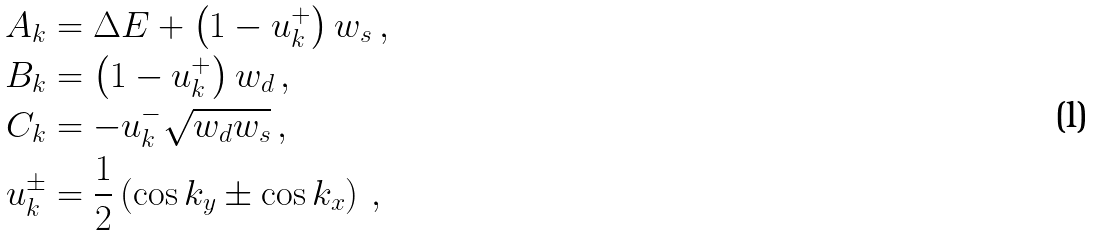<formula> <loc_0><loc_0><loc_500><loc_500>A _ { k } & = \Delta E + \left ( 1 - u _ { k } ^ { + } \right ) w _ { s } \, , \\ B _ { k } & = \left ( 1 - u _ { k } ^ { + } \right ) w _ { d } \, , \\ C _ { k } & = - u _ { k } ^ { - } \sqrt { w _ { d } w _ { s } } \, , \\ u _ { k } ^ { \pm } & = \frac { 1 } { 2 } \left ( \cos k _ { y } \pm \cos k _ { x } \right ) \, ,</formula> 